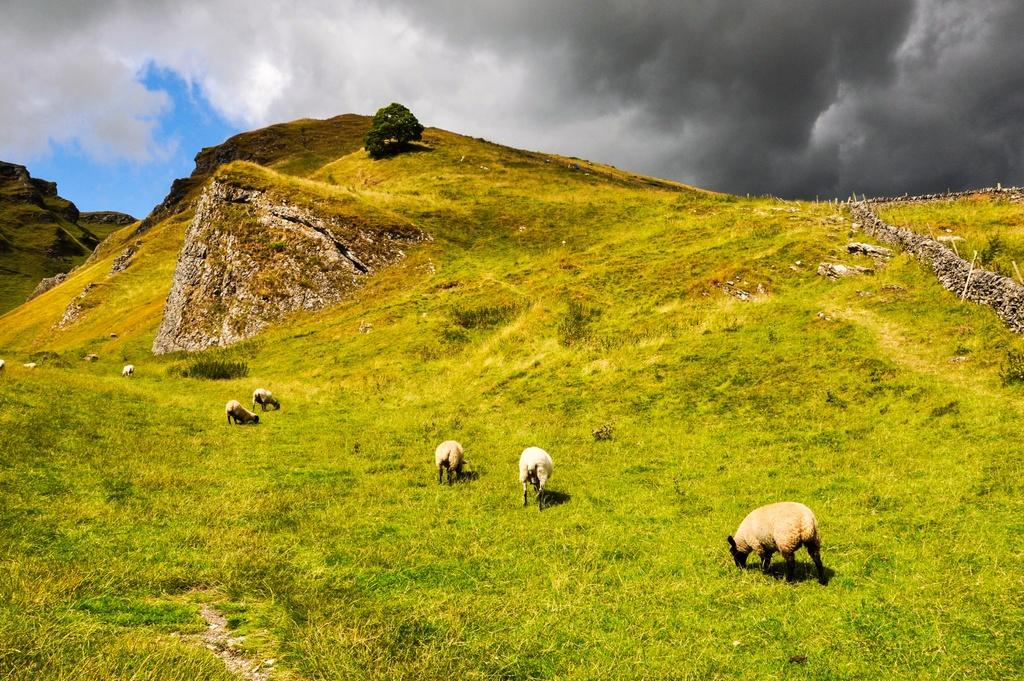What animals are present in the image? There are sheep standing on the ground in the image. What type of vegetation can be seen in the background of the image? There is grass visible in the background of the image. What geographical features are in the background of the image? There are hills in the background of the image. Can you describe the natural environment in the image? There is a tree and grass visible in the background, along with hills and the sky. What type of lettuce is being served on the plate in the image? There is no plate or lettuce present in the image; it features sheep standing on the ground with a natural background. How many cherries are hanging from the tree in the image? There is no tree with cherries in the image; it features a tree with leaves and no visible fruit. 